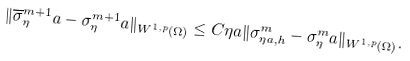<formula> <loc_0><loc_0><loc_500><loc_500>\| \overline { \sigma } ^ { m + 1 } _ { \eta } a - \sigma ^ { m + 1 } _ { \eta } a \| _ { W ^ { 1 , p } ( \Omega ) } \leq C \eta a \| \sigma ^ { m } _ { \eta a , h } - \sigma ^ { m } _ { \eta } a \| _ { W ^ { 1 , p } ( \Omega ) } .</formula> 